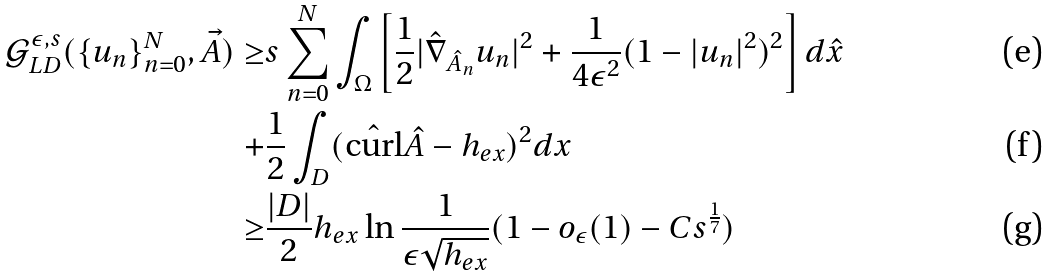<formula> <loc_0><loc_0><loc_500><loc_500>\mathcal { G } _ { L D } ^ { \epsilon , s } ( \{ u _ { n } \} _ { n = 0 } ^ { N } , \vec { A } ) \geq & s \sum ^ { N } _ { n = 0 } \int _ { \Omega } \left [ \frac { 1 } { 2 } | \hat { \nabla } _ { \hat { A } _ { n } } u _ { n } | ^ { 2 } + \frac { 1 } { 4 \epsilon ^ { 2 } } ( 1 - | u _ { n } | ^ { 2 } ) ^ { 2 } \right ] d \hat { x } \\ + & \frac { 1 } { 2 } \int _ { D } ( \hat { \text {curl} } \hat { A } - h _ { e x } ) ^ { 2 } d x \\ \geq & \frac { | D | } { 2 } h _ { e x } \ln \frac { 1 } { \epsilon \sqrt { h _ { e x } } } ( 1 - o _ { \epsilon } ( 1 ) - C s ^ { \frac { 1 } { 7 } } )</formula> 